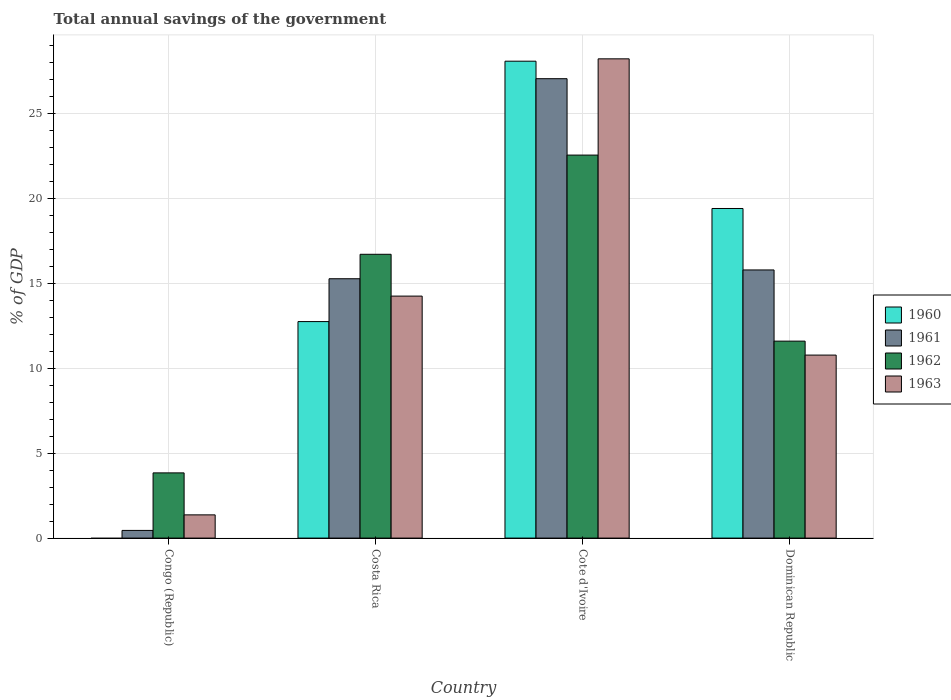Are the number of bars per tick equal to the number of legend labels?
Give a very brief answer. No. Are the number of bars on each tick of the X-axis equal?
Give a very brief answer. No. What is the label of the 4th group of bars from the left?
Your answer should be very brief. Dominican Republic. What is the total annual savings of the government in 1962 in Congo (Republic)?
Your answer should be compact. 3.84. Across all countries, what is the maximum total annual savings of the government in 1963?
Ensure brevity in your answer.  28.2. Across all countries, what is the minimum total annual savings of the government in 1962?
Your answer should be compact. 3.84. In which country was the total annual savings of the government in 1962 maximum?
Make the answer very short. Cote d'Ivoire. What is the total total annual savings of the government in 1962 in the graph?
Make the answer very short. 54.66. What is the difference between the total annual savings of the government in 1962 in Congo (Republic) and that in Cote d'Ivoire?
Offer a terse response. -18.7. What is the difference between the total annual savings of the government in 1961 in Costa Rica and the total annual savings of the government in 1960 in Congo (Republic)?
Offer a terse response. 15.26. What is the average total annual savings of the government in 1960 per country?
Provide a succinct answer. 15.05. What is the difference between the total annual savings of the government of/in 1962 and total annual savings of the government of/in 1960 in Costa Rica?
Give a very brief answer. 3.96. In how many countries, is the total annual savings of the government in 1960 greater than 15 %?
Give a very brief answer. 2. What is the ratio of the total annual savings of the government in 1961 in Costa Rica to that in Dominican Republic?
Your answer should be very brief. 0.97. What is the difference between the highest and the second highest total annual savings of the government in 1961?
Offer a very short reply. 11.77. What is the difference between the highest and the lowest total annual savings of the government in 1963?
Your answer should be very brief. 26.83. In how many countries, is the total annual savings of the government in 1960 greater than the average total annual savings of the government in 1960 taken over all countries?
Keep it short and to the point. 2. How many bars are there?
Make the answer very short. 15. Are all the bars in the graph horizontal?
Your answer should be compact. No. Are the values on the major ticks of Y-axis written in scientific E-notation?
Ensure brevity in your answer.  No. How many legend labels are there?
Your answer should be very brief. 4. How are the legend labels stacked?
Your answer should be compact. Vertical. What is the title of the graph?
Give a very brief answer. Total annual savings of the government. What is the label or title of the X-axis?
Provide a short and direct response. Country. What is the label or title of the Y-axis?
Offer a terse response. % of GDP. What is the % of GDP in 1961 in Congo (Republic)?
Your answer should be compact. 0.45. What is the % of GDP in 1962 in Congo (Republic)?
Ensure brevity in your answer.  3.84. What is the % of GDP of 1963 in Congo (Republic)?
Your answer should be very brief. 1.37. What is the % of GDP of 1960 in Costa Rica?
Your answer should be very brief. 12.74. What is the % of GDP of 1961 in Costa Rica?
Ensure brevity in your answer.  15.26. What is the % of GDP in 1962 in Costa Rica?
Keep it short and to the point. 16.7. What is the % of GDP in 1963 in Costa Rica?
Give a very brief answer. 14.24. What is the % of GDP in 1960 in Cote d'Ivoire?
Your answer should be compact. 28.06. What is the % of GDP of 1961 in Cote d'Ivoire?
Your answer should be compact. 27.03. What is the % of GDP of 1962 in Cote d'Ivoire?
Offer a very short reply. 22.54. What is the % of GDP of 1963 in Cote d'Ivoire?
Make the answer very short. 28.2. What is the % of GDP of 1960 in Dominican Republic?
Keep it short and to the point. 19.39. What is the % of GDP in 1961 in Dominican Republic?
Ensure brevity in your answer.  15.78. What is the % of GDP in 1962 in Dominican Republic?
Ensure brevity in your answer.  11.59. What is the % of GDP of 1963 in Dominican Republic?
Your answer should be compact. 10.77. Across all countries, what is the maximum % of GDP of 1960?
Provide a short and direct response. 28.06. Across all countries, what is the maximum % of GDP of 1961?
Offer a terse response. 27.03. Across all countries, what is the maximum % of GDP of 1962?
Provide a short and direct response. 22.54. Across all countries, what is the maximum % of GDP of 1963?
Ensure brevity in your answer.  28.2. Across all countries, what is the minimum % of GDP in 1961?
Your response must be concise. 0.45. Across all countries, what is the minimum % of GDP of 1962?
Your answer should be compact. 3.84. Across all countries, what is the minimum % of GDP in 1963?
Keep it short and to the point. 1.37. What is the total % of GDP of 1960 in the graph?
Provide a succinct answer. 60.19. What is the total % of GDP in 1961 in the graph?
Your response must be concise. 58.52. What is the total % of GDP in 1962 in the graph?
Provide a short and direct response. 54.66. What is the total % of GDP in 1963 in the graph?
Your answer should be compact. 54.57. What is the difference between the % of GDP of 1961 in Congo (Republic) and that in Costa Rica?
Provide a short and direct response. -14.81. What is the difference between the % of GDP in 1962 in Congo (Republic) and that in Costa Rica?
Offer a terse response. -12.86. What is the difference between the % of GDP of 1963 in Congo (Republic) and that in Costa Rica?
Provide a short and direct response. -12.87. What is the difference between the % of GDP in 1961 in Congo (Republic) and that in Cote d'Ivoire?
Your response must be concise. -26.58. What is the difference between the % of GDP in 1962 in Congo (Republic) and that in Cote d'Ivoire?
Provide a succinct answer. -18.7. What is the difference between the % of GDP in 1963 in Congo (Republic) and that in Cote d'Ivoire?
Provide a succinct answer. -26.83. What is the difference between the % of GDP in 1961 in Congo (Republic) and that in Dominican Republic?
Your answer should be very brief. -15.33. What is the difference between the % of GDP of 1962 in Congo (Republic) and that in Dominican Republic?
Ensure brevity in your answer.  -7.75. What is the difference between the % of GDP of 1963 in Congo (Republic) and that in Dominican Republic?
Provide a short and direct response. -9.4. What is the difference between the % of GDP in 1960 in Costa Rica and that in Cote d'Ivoire?
Your answer should be compact. -15.32. What is the difference between the % of GDP of 1961 in Costa Rica and that in Cote d'Ivoire?
Your answer should be compact. -11.77. What is the difference between the % of GDP of 1962 in Costa Rica and that in Cote d'Ivoire?
Give a very brief answer. -5.84. What is the difference between the % of GDP in 1963 in Costa Rica and that in Cote d'Ivoire?
Your answer should be compact. -13.96. What is the difference between the % of GDP of 1960 in Costa Rica and that in Dominican Republic?
Offer a terse response. -6.65. What is the difference between the % of GDP of 1961 in Costa Rica and that in Dominican Republic?
Your response must be concise. -0.52. What is the difference between the % of GDP of 1962 in Costa Rica and that in Dominican Republic?
Provide a succinct answer. 5.11. What is the difference between the % of GDP in 1963 in Costa Rica and that in Dominican Republic?
Your answer should be very brief. 3.47. What is the difference between the % of GDP in 1960 in Cote d'Ivoire and that in Dominican Republic?
Provide a short and direct response. 8.67. What is the difference between the % of GDP of 1961 in Cote d'Ivoire and that in Dominican Republic?
Your answer should be compact. 11.25. What is the difference between the % of GDP of 1962 in Cote d'Ivoire and that in Dominican Republic?
Provide a succinct answer. 10.95. What is the difference between the % of GDP of 1963 in Cote d'Ivoire and that in Dominican Republic?
Give a very brief answer. 17.43. What is the difference between the % of GDP in 1961 in Congo (Republic) and the % of GDP in 1962 in Costa Rica?
Your answer should be very brief. -16.25. What is the difference between the % of GDP in 1961 in Congo (Republic) and the % of GDP in 1963 in Costa Rica?
Offer a terse response. -13.79. What is the difference between the % of GDP of 1962 in Congo (Republic) and the % of GDP of 1963 in Costa Rica?
Provide a succinct answer. -10.4. What is the difference between the % of GDP in 1961 in Congo (Republic) and the % of GDP in 1962 in Cote d'Ivoire?
Your response must be concise. -22.08. What is the difference between the % of GDP in 1961 in Congo (Republic) and the % of GDP in 1963 in Cote d'Ivoire?
Your response must be concise. -27.75. What is the difference between the % of GDP in 1962 in Congo (Republic) and the % of GDP in 1963 in Cote d'Ivoire?
Your response must be concise. -24.36. What is the difference between the % of GDP in 1961 in Congo (Republic) and the % of GDP in 1962 in Dominican Republic?
Keep it short and to the point. -11.14. What is the difference between the % of GDP of 1961 in Congo (Republic) and the % of GDP of 1963 in Dominican Republic?
Ensure brevity in your answer.  -10.32. What is the difference between the % of GDP in 1962 in Congo (Republic) and the % of GDP in 1963 in Dominican Republic?
Your answer should be very brief. -6.93. What is the difference between the % of GDP in 1960 in Costa Rica and the % of GDP in 1961 in Cote d'Ivoire?
Keep it short and to the point. -14.29. What is the difference between the % of GDP in 1960 in Costa Rica and the % of GDP in 1962 in Cote d'Ivoire?
Make the answer very short. -9.8. What is the difference between the % of GDP of 1960 in Costa Rica and the % of GDP of 1963 in Cote d'Ivoire?
Give a very brief answer. -15.46. What is the difference between the % of GDP of 1961 in Costa Rica and the % of GDP of 1962 in Cote d'Ivoire?
Give a very brief answer. -7.28. What is the difference between the % of GDP in 1961 in Costa Rica and the % of GDP in 1963 in Cote d'Ivoire?
Keep it short and to the point. -12.94. What is the difference between the % of GDP in 1962 in Costa Rica and the % of GDP in 1963 in Cote d'Ivoire?
Provide a succinct answer. -11.5. What is the difference between the % of GDP of 1960 in Costa Rica and the % of GDP of 1961 in Dominican Republic?
Provide a short and direct response. -3.04. What is the difference between the % of GDP in 1960 in Costa Rica and the % of GDP in 1962 in Dominican Republic?
Your response must be concise. 1.15. What is the difference between the % of GDP of 1960 in Costa Rica and the % of GDP of 1963 in Dominican Republic?
Keep it short and to the point. 1.97. What is the difference between the % of GDP of 1961 in Costa Rica and the % of GDP of 1962 in Dominican Republic?
Provide a short and direct response. 3.67. What is the difference between the % of GDP of 1961 in Costa Rica and the % of GDP of 1963 in Dominican Republic?
Give a very brief answer. 4.49. What is the difference between the % of GDP in 1962 in Costa Rica and the % of GDP in 1963 in Dominican Republic?
Your answer should be compact. 5.93. What is the difference between the % of GDP in 1960 in Cote d'Ivoire and the % of GDP in 1961 in Dominican Republic?
Your answer should be very brief. 12.28. What is the difference between the % of GDP in 1960 in Cote d'Ivoire and the % of GDP in 1962 in Dominican Republic?
Your answer should be compact. 16.47. What is the difference between the % of GDP in 1960 in Cote d'Ivoire and the % of GDP in 1963 in Dominican Republic?
Provide a short and direct response. 17.29. What is the difference between the % of GDP in 1961 in Cote d'Ivoire and the % of GDP in 1962 in Dominican Republic?
Make the answer very short. 15.44. What is the difference between the % of GDP in 1961 in Cote d'Ivoire and the % of GDP in 1963 in Dominican Republic?
Offer a very short reply. 16.26. What is the difference between the % of GDP of 1962 in Cote d'Ivoire and the % of GDP of 1963 in Dominican Republic?
Offer a very short reply. 11.77. What is the average % of GDP of 1960 per country?
Offer a very short reply. 15.05. What is the average % of GDP of 1961 per country?
Offer a terse response. 14.63. What is the average % of GDP of 1962 per country?
Your answer should be very brief. 13.66. What is the average % of GDP in 1963 per country?
Ensure brevity in your answer.  13.64. What is the difference between the % of GDP of 1961 and % of GDP of 1962 in Congo (Republic)?
Offer a terse response. -3.38. What is the difference between the % of GDP in 1961 and % of GDP in 1963 in Congo (Republic)?
Make the answer very short. -0.91. What is the difference between the % of GDP in 1962 and % of GDP in 1963 in Congo (Republic)?
Your answer should be compact. 2.47. What is the difference between the % of GDP in 1960 and % of GDP in 1961 in Costa Rica?
Offer a very short reply. -2.52. What is the difference between the % of GDP of 1960 and % of GDP of 1962 in Costa Rica?
Give a very brief answer. -3.96. What is the difference between the % of GDP of 1960 and % of GDP of 1963 in Costa Rica?
Give a very brief answer. -1.5. What is the difference between the % of GDP of 1961 and % of GDP of 1962 in Costa Rica?
Keep it short and to the point. -1.44. What is the difference between the % of GDP of 1961 and % of GDP of 1963 in Costa Rica?
Make the answer very short. 1.02. What is the difference between the % of GDP in 1962 and % of GDP in 1963 in Costa Rica?
Ensure brevity in your answer.  2.46. What is the difference between the % of GDP of 1960 and % of GDP of 1962 in Cote d'Ivoire?
Provide a succinct answer. 5.52. What is the difference between the % of GDP of 1960 and % of GDP of 1963 in Cote d'Ivoire?
Your answer should be very brief. -0.14. What is the difference between the % of GDP in 1961 and % of GDP in 1962 in Cote d'Ivoire?
Offer a very short reply. 4.49. What is the difference between the % of GDP in 1961 and % of GDP in 1963 in Cote d'Ivoire?
Make the answer very short. -1.17. What is the difference between the % of GDP in 1962 and % of GDP in 1963 in Cote d'Ivoire?
Your answer should be very brief. -5.66. What is the difference between the % of GDP in 1960 and % of GDP in 1961 in Dominican Republic?
Your answer should be compact. 3.62. What is the difference between the % of GDP of 1960 and % of GDP of 1962 in Dominican Republic?
Ensure brevity in your answer.  7.8. What is the difference between the % of GDP in 1960 and % of GDP in 1963 in Dominican Republic?
Your answer should be very brief. 8.63. What is the difference between the % of GDP in 1961 and % of GDP in 1962 in Dominican Republic?
Offer a very short reply. 4.19. What is the difference between the % of GDP in 1961 and % of GDP in 1963 in Dominican Republic?
Provide a short and direct response. 5.01. What is the difference between the % of GDP of 1962 and % of GDP of 1963 in Dominican Republic?
Ensure brevity in your answer.  0.82. What is the ratio of the % of GDP in 1961 in Congo (Republic) to that in Costa Rica?
Offer a terse response. 0.03. What is the ratio of the % of GDP of 1962 in Congo (Republic) to that in Costa Rica?
Ensure brevity in your answer.  0.23. What is the ratio of the % of GDP in 1963 in Congo (Republic) to that in Costa Rica?
Provide a succinct answer. 0.1. What is the ratio of the % of GDP in 1961 in Congo (Republic) to that in Cote d'Ivoire?
Offer a terse response. 0.02. What is the ratio of the % of GDP in 1962 in Congo (Republic) to that in Cote d'Ivoire?
Offer a very short reply. 0.17. What is the ratio of the % of GDP of 1963 in Congo (Republic) to that in Cote d'Ivoire?
Give a very brief answer. 0.05. What is the ratio of the % of GDP of 1961 in Congo (Republic) to that in Dominican Republic?
Ensure brevity in your answer.  0.03. What is the ratio of the % of GDP of 1962 in Congo (Republic) to that in Dominican Republic?
Make the answer very short. 0.33. What is the ratio of the % of GDP of 1963 in Congo (Republic) to that in Dominican Republic?
Give a very brief answer. 0.13. What is the ratio of the % of GDP of 1960 in Costa Rica to that in Cote d'Ivoire?
Your response must be concise. 0.45. What is the ratio of the % of GDP of 1961 in Costa Rica to that in Cote d'Ivoire?
Your answer should be compact. 0.56. What is the ratio of the % of GDP in 1962 in Costa Rica to that in Cote d'Ivoire?
Ensure brevity in your answer.  0.74. What is the ratio of the % of GDP in 1963 in Costa Rica to that in Cote d'Ivoire?
Provide a short and direct response. 0.5. What is the ratio of the % of GDP of 1960 in Costa Rica to that in Dominican Republic?
Your answer should be compact. 0.66. What is the ratio of the % of GDP of 1961 in Costa Rica to that in Dominican Republic?
Offer a very short reply. 0.97. What is the ratio of the % of GDP in 1962 in Costa Rica to that in Dominican Republic?
Your response must be concise. 1.44. What is the ratio of the % of GDP of 1963 in Costa Rica to that in Dominican Republic?
Make the answer very short. 1.32. What is the ratio of the % of GDP of 1960 in Cote d'Ivoire to that in Dominican Republic?
Provide a short and direct response. 1.45. What is the ratio of the % of GDP in 1961 in Cote d'Ivoire to that in Dominican Republic?
Provide a succinct answer. 1.71. What is the ratio of the % of GDP in 1962 in Cote d'Ivoire to that in Dominican Republic?
Make the answer very short. 1.94. What is the ratio of the % of GDP in 1963 in Cote d'Ivoire to that in Dominican Republic?
Make the answer very short. 2.62. What is the difference between the highest and the second highest % of GDP of 1960?
Your answer should be compact. 8.67. What is the difference between the highest and the second highest % of GDP in 1961?
Give a very brief answer. 11.25. What is the difference between the highest and the second highest % of GDP in 1962?
Keep it short and to the point. 5.84. What is the difference between the highest and the second highest % of GDP of 1963?
Your response must be concise. 13.96. What is the difference between the highest and the lowest % of GDP in 1960?
Ensure brevity in your answer.  28.06. What is the difference between the highest and the lowest % of GDP in 1961?
Your answer should be compact. 26.58. What is the difference between the highest and the lowest % of GDP in 1962?
Make the answer very short. 18.7. What is the difference between the highest and the lowest % of GDP in 1963?
Offer a terse response. 26.83. 